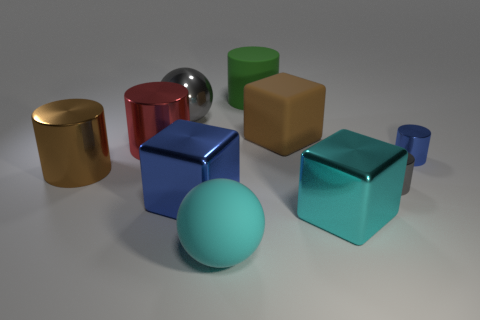Subtract all blue shiny cylinders. How many cylinders are left? 4 Subtract all red cylinders. How many cylinders are left? 4 Subtract 1 cylinders. How many cylinders are left? 4 Subtract all green cylinders. Subtract all brown spheres. How many cylinders are left? 4 Subtract all balls. How many objects are left? 8 Add 5 big blue objects. How many big blue objects are left? 6 Add 8 small shiny cubes. How many small shiny cubes exist? 8 Subtract 0 yellow cubes. How many objects are left? 10 Subtract all big blue matte blocks. Subtract all large metallic cylinders. How many objects are left? 8 